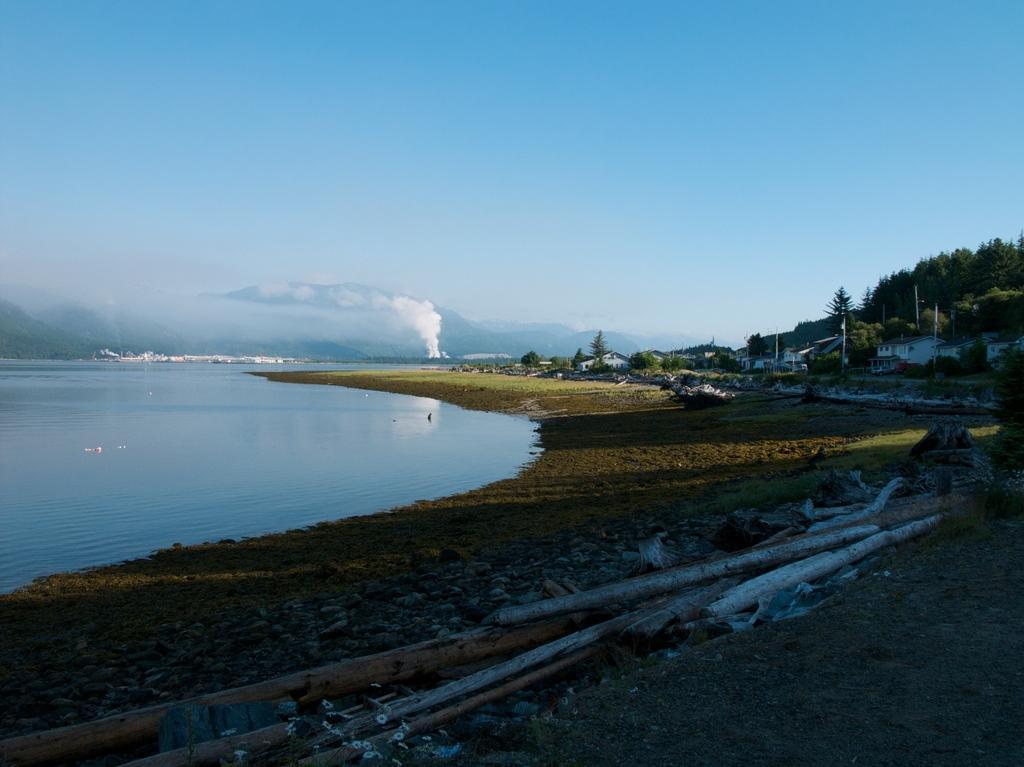How would you summarize this image in a sentence or two? In this image I can see the ground, few wooden logs on the ground, some grass on the ground and the water. In the background I can see few trees, few buildings, some smoke, few mountains and the sky. 